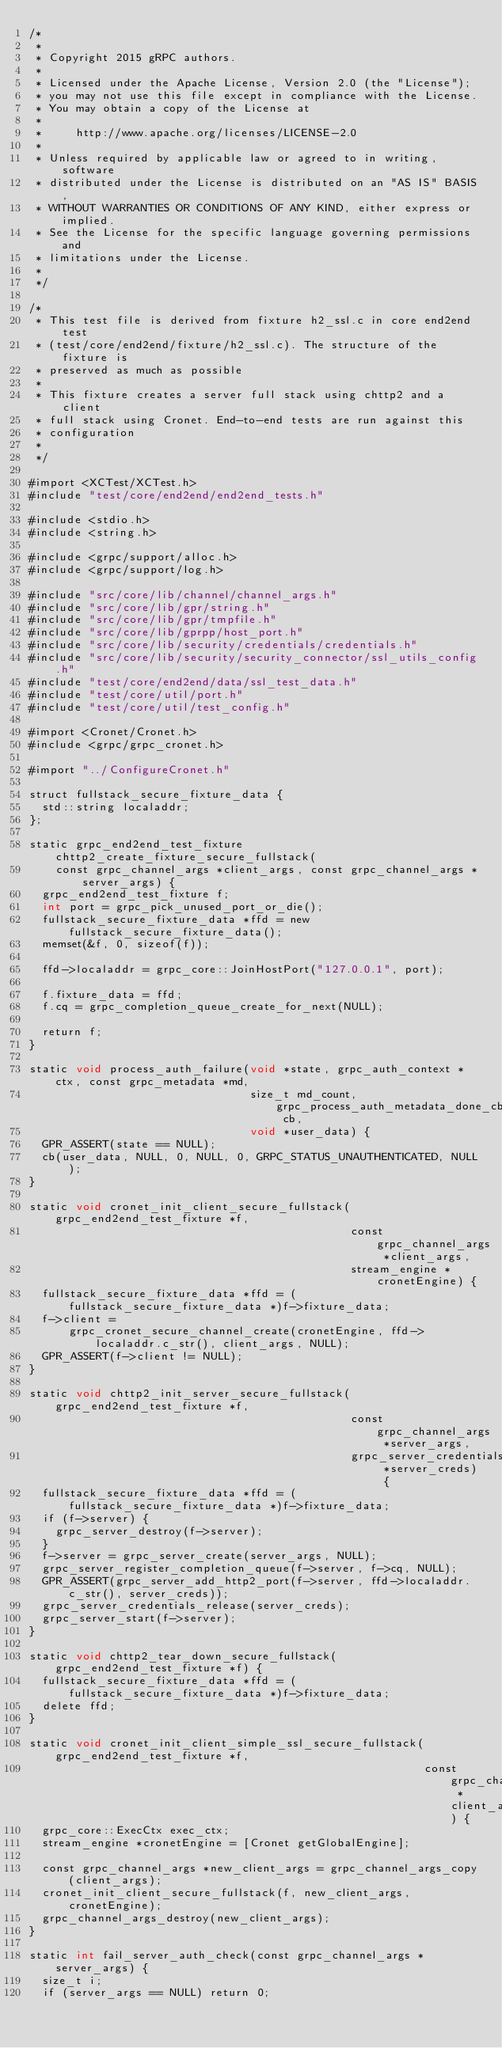Convert code to text. <code><loc_0><loc_0><loc_500><loc_500><_ObjectiveC_>/*
 *
 * Copyright 2015 gRPC authors.
 *
 * Licensed under the Apache License, Version 2.0 (the "License");
 * you may not use this file except in compliance with the License.
 * You may obtain a copy of the License at
 *
 *     http://www.apache.org/licenses/LICENSE-2.0
 *
 * Unless required by applicable law or agreed to in writing, software
 * distributed under the License is distributed on an "AS IS" BASIS,
 * WITHOUT WARRANTIES OR CONDITIONS OF ANY KIND, either express or implied.
 * See the License for the specific language governing permissions and
 * limitations under the License.
 *
 */

/*
 * This test file is derived from fixture h2_ssl.c in core end2end test
 * (test/core/end2end/fixture/h2_ssl.c). The structure of the fixture is
 * preserved as much as possible
 *
 * This fixture creates a server full stack using chttp2 and a client
 * full stack using Cronet. End-to-end tests are run against this
 * configuration
 *
 */

#import <XCTest/XCTest.h>
#include "test/core/end2end/end2end_tests.h"

#include <stdio.h>
#include <string.h>

#include <grpc/support/alloc.h>
#include <grpc/support/log.h>

#include "src/core/lib/channel/channel_args.h"
#include "src/core/lib/gpr/string.h"
#include "src/core/lib/gpr/tmpfile.h"
#include "src/core/lib/gprpp/host_port.h"
#include "src/core/lib/security/credentials/credentials.h"
#include "src/core/lib/security/security_connector/ssl_utils_config.h"
#include "test/core/end2end/data/ssl_test_data.h"
#include "test/core/util/port.h"
#include "test/core/util/test_config.h"

#import <Cronet/Cronet.h>
#include <grpc/grpc_cronet.h>

#import "../ConfigureCronet.h"

struct fullstack_secure_fixture_data {
  std::string localaddr;
};

static grpc_end2end_test_fixture chttp2_create_fixture_secure_fullstack(
    const grpc_channel_args *client_args, const grpc_channel_args *server_args) {
  grpc_end2end_test_fixture f;
  int port = grpc_pick_unused_port_or_die();
  fullstack_secure_fixture_data *ffd = new fullstack_secure_fixture_data();
  memset(&f, 0, sizeof(f));

  ffd->localaddr = grpc_core::JoinHostPort("127.0.0.1", port);

  f.fixture_data = ffd;
  f.cq = grpc_completion_queue_create_for_next(NULL);

  return f;
}

static void process_auth_failure(void *state, grpc_auth_context *ctx, const grpc_metadata *md,
                                 size_t md_count, grpc_process_auth_metadata_done_cb cb,
                                 void *user_data) {
  GPR_ASSERT(state == NULL);
  cb(user_data, NULL, 0, NULL, 0, GRPC_STATUS_UNAUTHENTICATED, NULL);
}

static void cronet_init_client_secure_fullstack(grpc_end2end_test_fixture *f,
                                                const grpc_channel_args *client_args,
                                                stream_engine *cronetEngine) {
  fullstack_secure_fixture_data *ffd = (fullstack_secure_fixture_data *)f->fixture_data;
  f->client =
      grpc_cronet_secure_channel_create(cronetEngine, ffd->localaddr.c_str(), client_args, NULL);
  GPR_ASSERT(f->client != NULL);
}

static void chttp2_init_server_secure_fullstack(grpc_end2end_test_fixture *f,
                                                const grpc_channel_args *server_args,
                                                grpc_server_credentials *server_creds) {
  fullstack_secure_fixture_data *ffd = (fullstack_secure_fixture_data *)f->fixture_data;
  if (f->server) {
    grpc_server_destroy(f->server);
  }
  f->server = grpc_server_create(server_args, NULL);
  grpc_server_register_completion_queue(f->server, f->cq, NULL);
  GPR_ASSERT(grpc_server_add_http2_port(f->server, ffd->localaddr.c_str(), server_creds));
  grpc_server_credentials_release(server_creds);
  grpc_server_start(f->server);
}

static void chttp2_tear_down_secure_fullstack(grpc_end2end_test_fixture *f) {
  fullstack_secure_fixture_data *ffd = (fullstack_secure_fixture_data *)f->fixture_data;
  delete ffd;
}

static void cronet_init_client_simple_ssl_secure_fullstack(grpc_end2end_test_fixture *f,
                                                           const grpc_channel_args *client_args) {
  grpc_core::ExecCtx exec_ctx;
  stream_engine *cronetEngine = [Cronet getGlobalEngine];

  const grpc_channel_args *new_client_args = grpc_channel_args_copy(client_args);
  cronet_init_client_secure_fullstack(f, new_client_args, cronetEngine);
  grpc_channel_args_destroy(new_client_args);
}

static int fail_server_auth_check(const grpc_channel_args *server_args) {
  size_t i;
  if (server_args == NULL) return 0;</code> 